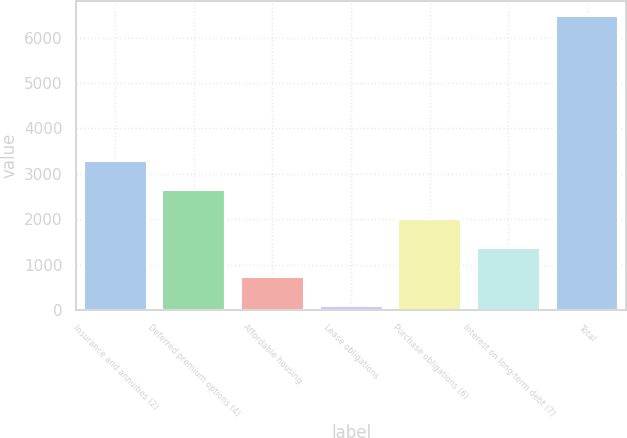Convert chart. <chart><loc_0><loc_0><loc_500><loc_500><bar_chart><fcel>Insurance and annuities (2)<fcel>Deferred premium options (4)<fcel>Affordable housing<fcel>Lease obligations<fcel>Purchase obligations (6)<fcel>Interest on long-term debt (7)<fcel>Total<nl><fcel>3277.5<fcel>2638.6<fcel>721.9<fcel>83<fcel>1999.7<fcel>1360.8<fcel>6472<nl></chart> 